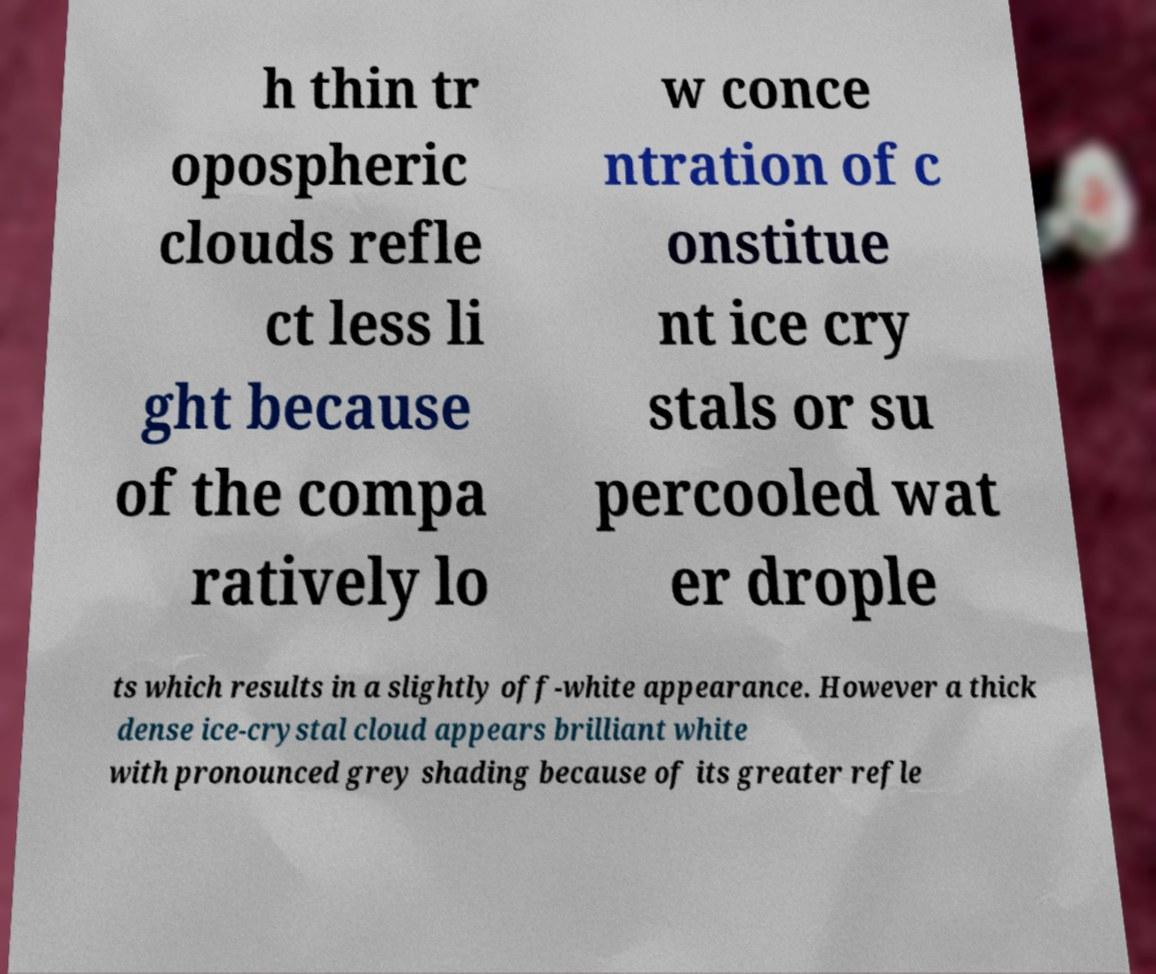I need the written content from this picture converted into text. Can you do that? h thin tr opospheric clouds refle ct less li ght because of the compa ratively lo w conce ntration of c onstitue nt ice cry stals or su percooled wat er drople ts which results in a slightly off-white appearance. However a thick dense ice-crystal cloud appears brilliant white with pronounced grey shading because of its greater refle 